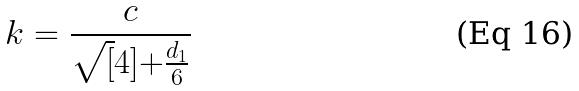<formula> <loc_0><loc_0><loc_500><loc_500>k = \frac { c } { \sqrt { [ } 4 ] { + \frac { d _ { 1 } } { 6 } } }</formula> 